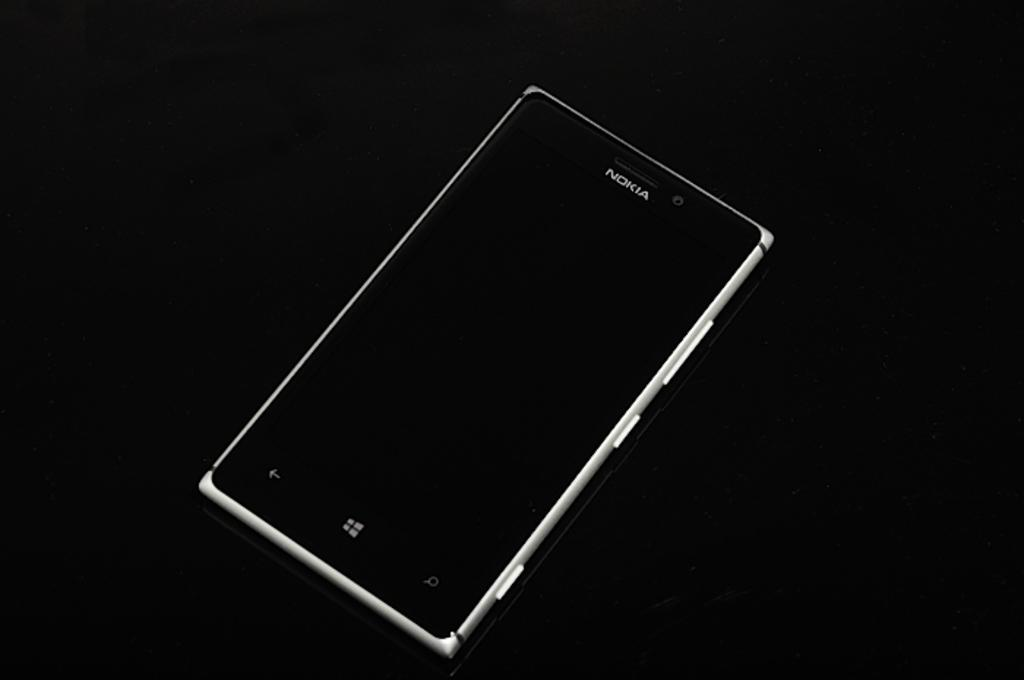<image>
Write a terse but informative summary of the picture. A black and silver Nokia rectangular Nokia Cellphone. 